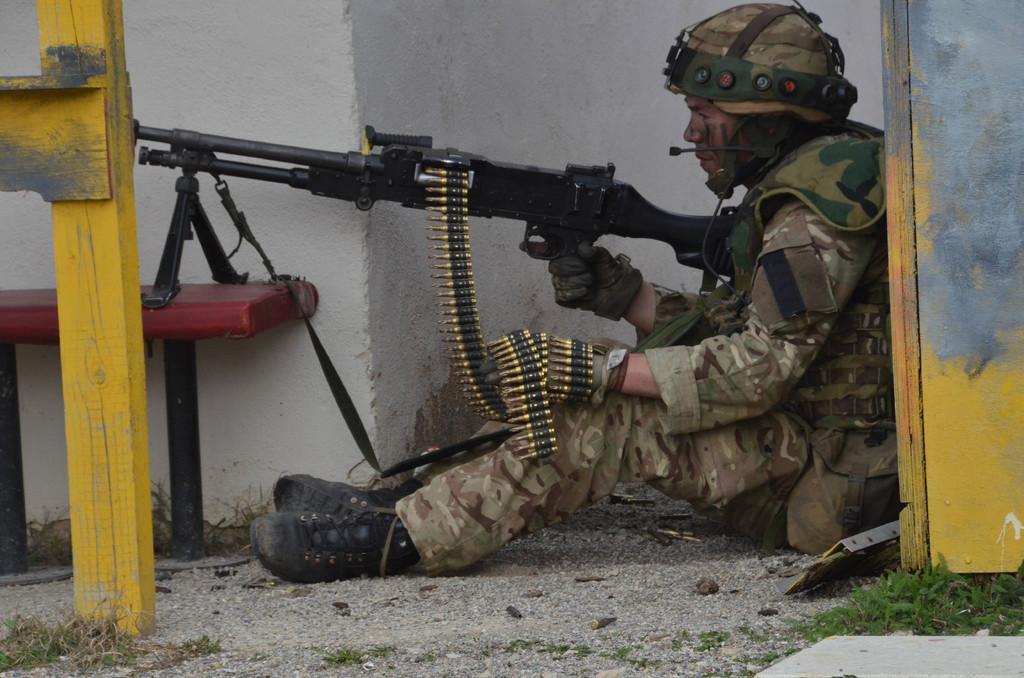Describe this image in one or two sentences. In this image, we can see a person is sitting on the ground and holding a gun. Here we can see bullets. On the right side of the image, we can see a wooden pole with door. Left side of the image, there is a yellow wooden pole and bench. Background there is white wall. At the bottom of the image, we can see few grasses. 